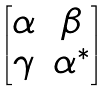<formula> <loc_0><loc_0><loc_500><loc_500>\begin{bmatrix} \alpha & \beta \\ \gamma & \alpha ^ { * } \end{bmatrix}</formula> 